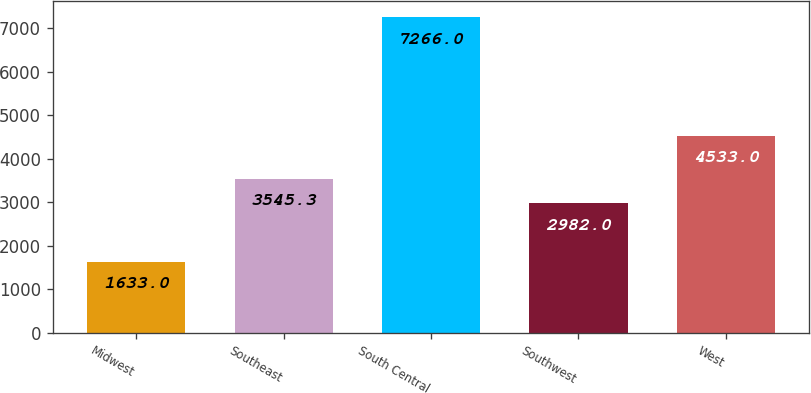Convert chart to OTSL. <chart><loc_0><loc_0><loc_500><loc_500><bar_chart><fcel>Midwest<fcel>Southeast<fcel>South Central<fcel>Southwest<fcel>West<nl><fcel>1633<fcel>3545.3<fcel>7266<fcel>2982<fcel>4533<nl></chart> 